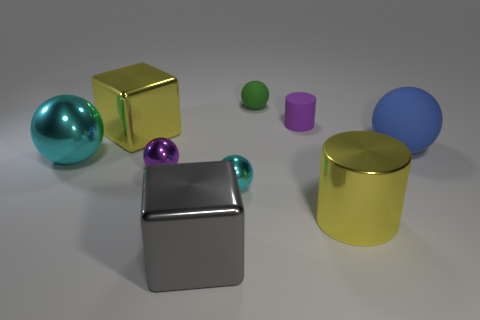Subtract all blue balls. How many balls are left? 4 Subtract all purple metallic balls. How many balls are left? 4 Subtract all purple balls. Subtract all blue cylinders. How many balls are left? 4 Subtract all balls. How many objects are left? 4 Add 2 cyan metallic objects. How many cyan metallic objects are left? 4 Add 7 big yellow metallic spheres. How many big yellow metallic spheres exist? 7 Subtract 0 green cylinders. How many objects are left? 9 Subtract all tiny purple things. Subtract all purple metallic things. How many objects are left? 6 